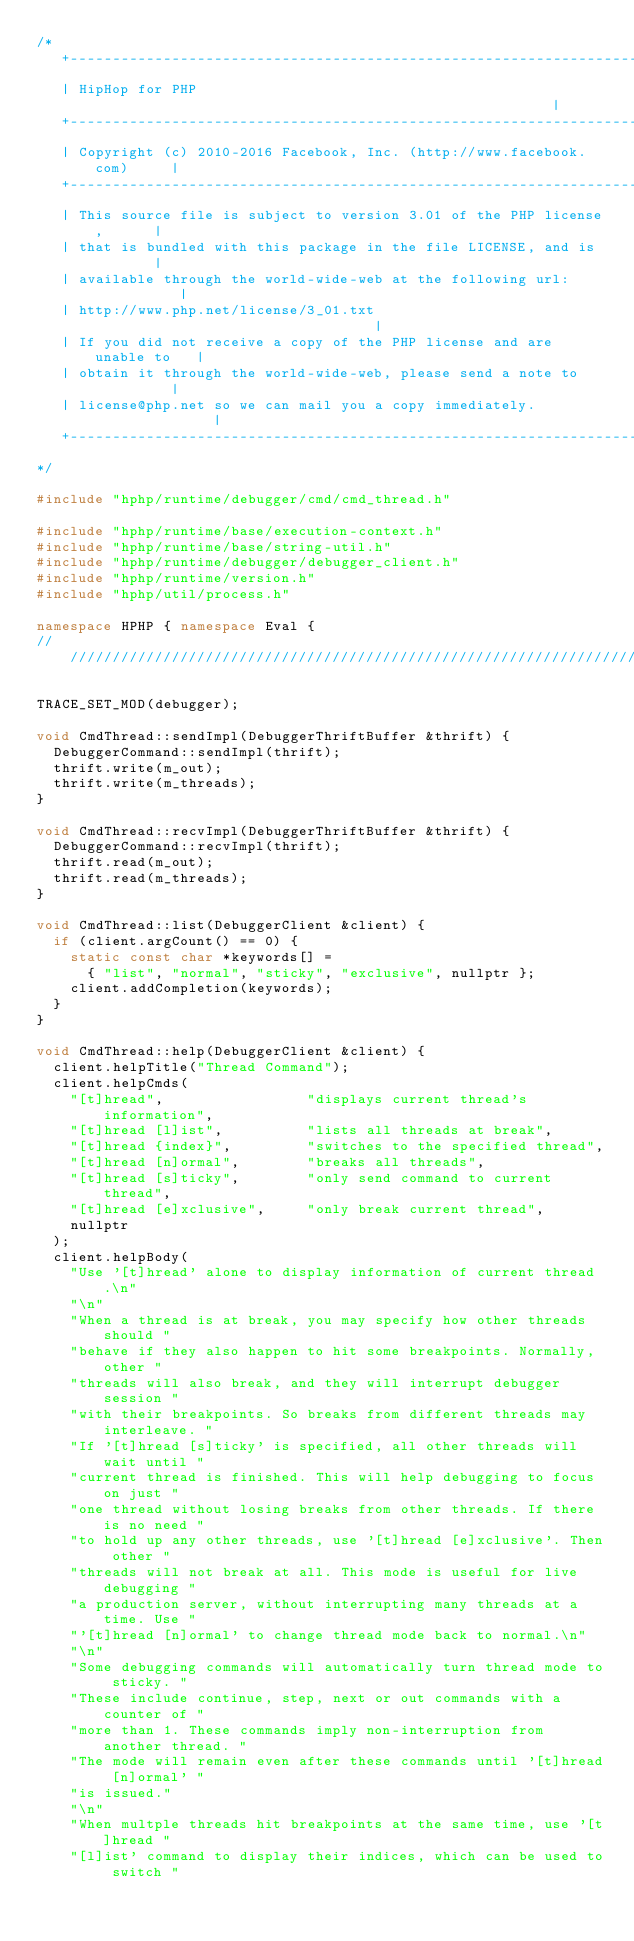Convert code to text. <code><loc_0><loc_0><loc_500><loc_500><_C++_>/*
   +----------------------------------------------------------------------+
   | HipHop for PHP                                                       |
   +----------------------------------------------------------------------+
   | Copyright (c) 2010-2016 Facebook, Inc. (http://www.facebook.com)     |
   +----------------------------------------------------------------------+
   | This source file is subject to version 3.01 of the PHP license,      |
   | that is bundled with this package in the file LICENSE, and is        |
   | available through the world-wide-web at the following url:           |
   | http://www.php.net/license/3_01.txt                                  |
   | If you did not receive a copy of the PHP license and are unable to   |
   | obtain it through the world-wide-web, please send a note to          |
   | license@php.net so we can mail you a copy immediately.               |
   +----------------------------------------------------------------------+
*/

#include "hphp/runtime/debugger/cmd/cmd_thread.h"

#include "hphp/runtime/base/execution-context.h"
#include "hphp/runtime/base/string-util.h"
#include "hphp/runtime/debugger/debugger_client.h"
#include "hphp/runtime/version.h"
#include "hphp/util/process.h"

namespace HPHP { namespace Eval {
///////////////////////////////////////////////////////////////////////////////

TRACE_SET_MOD(debugger);

void CmdThread::sendImpl(DebuggerThriftBuffer &thrift) {
  DebuggerCommand::sendImpl(thrift);
  thrift.write(m_out);
  thrift.write(m_threads);
}

void CmdThread::recvImpl(DebuggerThriftBuffer &thrift) {
  DebuggerCommand::recvImpl(thrift);
  thrift.read(m_out);
  thrift.read(m_threads);
}

void CmdThread::list(DebuggerClient &client) {
  if (client.argCount() == 0) {
    static const char *keywords[] =
      { "list", "normal", "sticky", "exclusive", nullptr };
    client.addCompletion(keywords);
  }
}

void CmdThread::help(DebuggerClient &client) {
  client.helpTitle("Thread Command");
  client.helpCmds(
    "[t]hread",                 "displays current thread's information",
    "[t]hread [l]ist",          "lists all threads at break",
    "[t]hread {index}",         "switches to the specified thread",
    "[t]hread [n]ormal",        "breaks all threads",
    "[t]hread [s]ticky",        "only send command to current thread",
    "[t]hread [e]xclusive",     "only break current thread",
    nullptr
  );
  client.helpBody(
    "Use '[t]hread' alone to display information of current thread.\n"
    "\n"
    "When a thread is at break, you may specify how other threads should "
    "behave if they also happen to hit some breakpoints. Normally, other "
    "threads will also break, and they will interrupt debugger session "
    "with their breakpoints. So breaks from different threads may interleave. "
    "If '[t]hread [s]ticky' is specified, all other threads will wait until "
    "current thread is finished. This will help debugging to focus on just "
    "one thread without losing breaks from other threads. If there is no need "
    "to hold up any other threads, use '[t]hread [e]xclusive'. Then other "
    "threads will not break at all. This mode is useful for live debugging "
    "a production server, without interrupting many threads at a time. Use "
    "'[t]hread [n]ormal' to change thread mode back to normal.\n"
    "\n"
    "Some debugging commands will automatically turn thread mode to sticky. "
    "These include continue, step, next or out commands with a counter of "
    "more than 1. These commands imply non-interruption from another thread. "
    "The mode will remain even after these commands until '[t]hread [n]ormal' "
    "is issued."
    "\n"
    "When multple threads hit breakpoints at the same time, use '[t]hread "
    "[l]ist' command to display their indices, which can be used to switch "</code> 